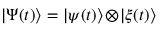Convert formula to latex. <formula><loc_0><loc_0><loc_500><loc_500>| \Psi ( t ) \rangle = | \psi ( t ) \rangle \, \otimes \, | \xi ( t ) \rangle</formula> 